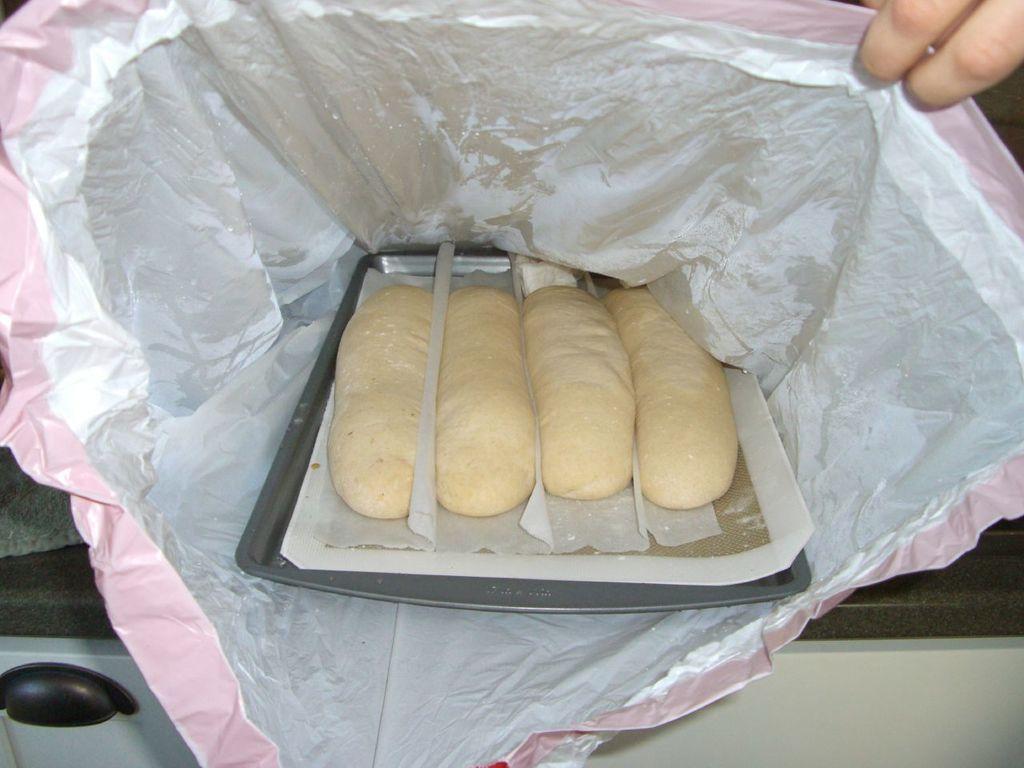Can you describe this image briefly? This image consist of food which is in the center. On the right side there are fingers of the person visible. 